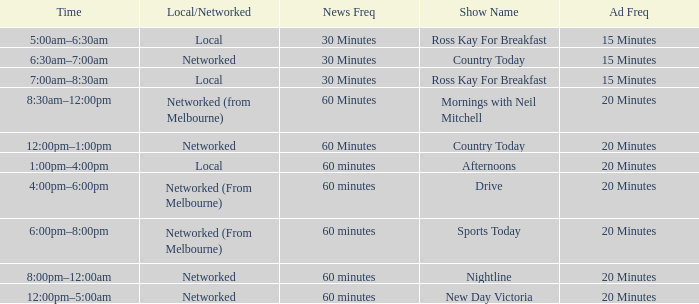What Local/Networked has a Show Name of nightline? Networked. 